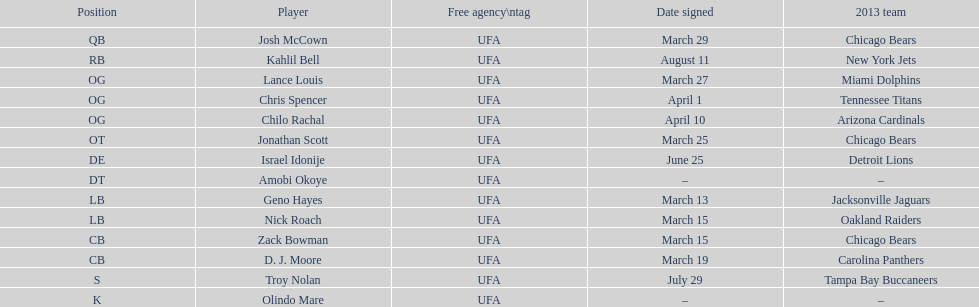How many free agents did this team pick up this season? 14. 